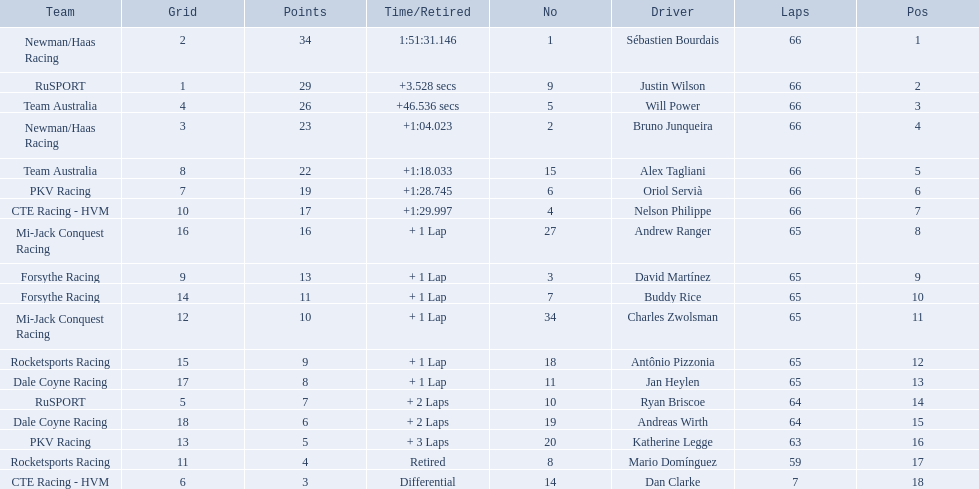What are the names of the drivers who were in position 14 through position 18? Ryan Briscoe, Andreas Wirth, Katherine Legge, Mario Domínguez, Dan Clarke. Of these , which ones didn't finish due to retired or differential? Mario Domínguez, Dan Clarke. Which one of the previous drivers retired? Mario Domínguez. Which of the drivers in question 2 had a differential? Dan Clarke. 